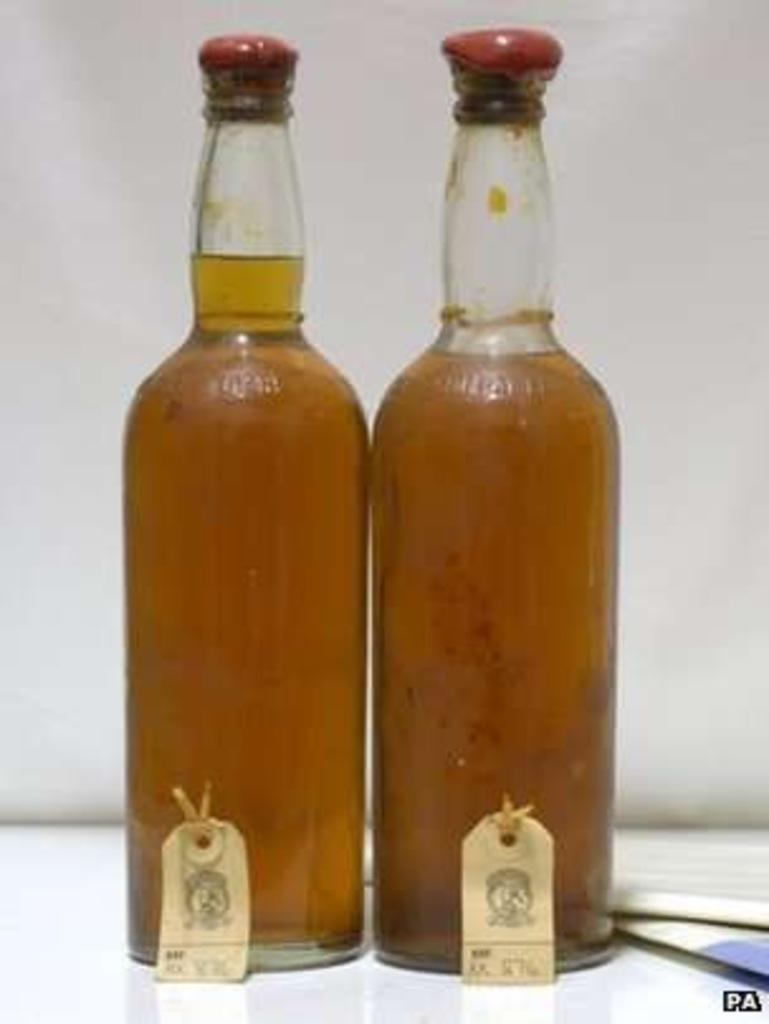How many bottles are visible in the image? There are two bottles in the image. What is inside the bottles? The bottles contain a liquid. How many women are using the pump in the image? There is no pump or women present in the image. What type of ear is visible in the image? There is no ear present in the image. 